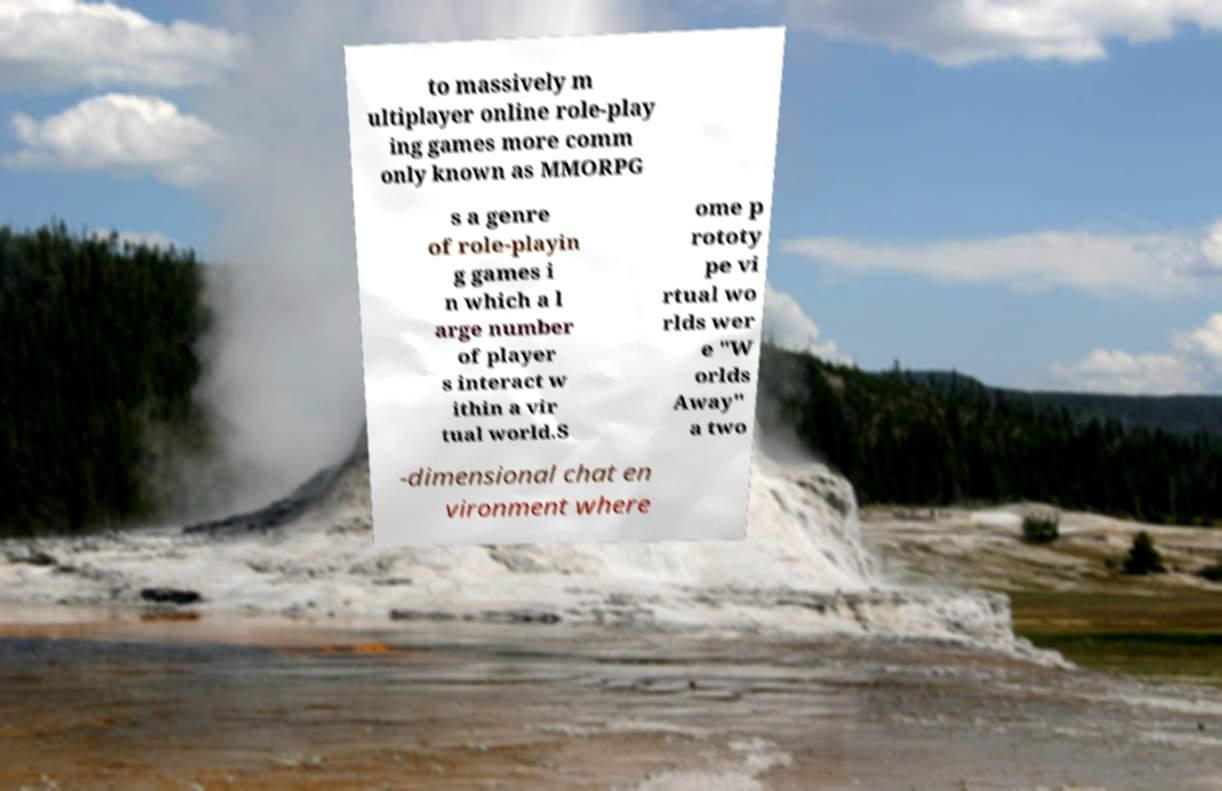What messages or text are displayed in this image? I need them in a readable, typed format. to massively m ultiplayer online role-play ing games more comm only known as MMORPG s a genre of role-playin g games i n which a l arge number of player s interact w ithin a vir tual world.S ome p rototy pe vi rtual wo rlds wer e "W orlds Away" a two -dimensional chat en vironment where 